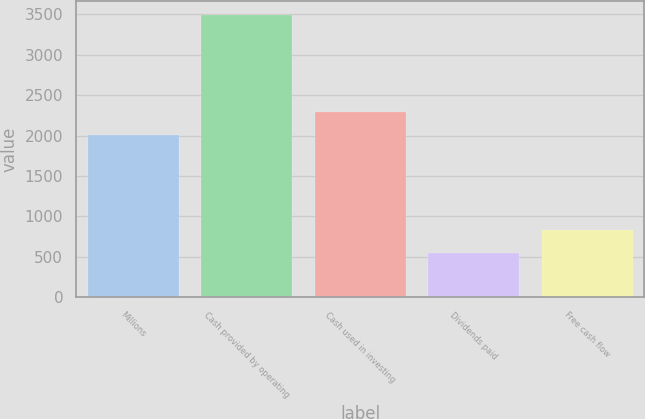<chart> <loc_0><loc_0><loc_500><loc_500><bar_chart><fcel>Millions<fcel>Cash provided by operating<fcel>Cash used in investing<fcel>Dividends paid<fcel>Free cash flow<nl><fcel>2009<fcel>3488.4<fcel>2293.4<fcel>544<fcel>828.4<nl></chart> 